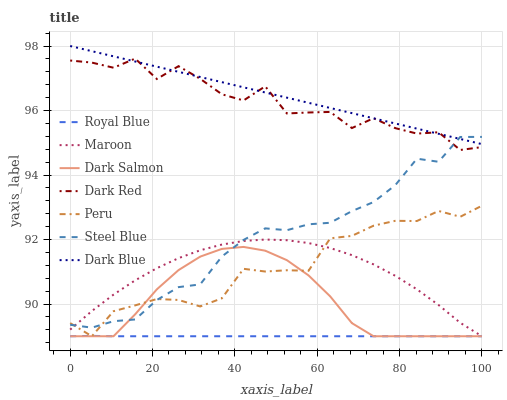Does Royal Blue have the minimum area under the curve?
Answer yes or no. Yes. Does Dark Blue have the maximum area under the curve?
Answer yes or no. Yes. Does Dark Red have the minimum area under the curve?
Answer yes or no. No. Does Dark Red have the maximum area under the curve?
Answer yes or no. No. Is Dark Blue the smoothest?
Answer yes or no. Yes. Is Dark Red the roughest?
Answer yes or no. Yes. Is Steel Blue the smoothest?
Answer yes or no. No. Is Steel Blue the roughest?
Answer yes or no. No. Does Maroon have the lowest value?
Answer yes or no. Yes. Does Dark Red have the lowest value?
Answer yes or no. No. Does Dark Blue have the highest value?
Answer yes or no. Yes. Does Dark Red have the highest value?
Answer yes or no. No. Is Maroon less than Dark Blue?
Answer yes or no. Yes. Is Dark Red greater than Maroon?
Answer yes or no. Yes. Does Steel Blue intersect Maroon?
Answer yes or no. Yes. Is Steel Blue less than Maroon?
Answer yes or no. No. Is Steel Blue greater than Maroon?
Answer yes or no. No. Does Maroon intersect Dark Blue?
Answer yes or no. No. 